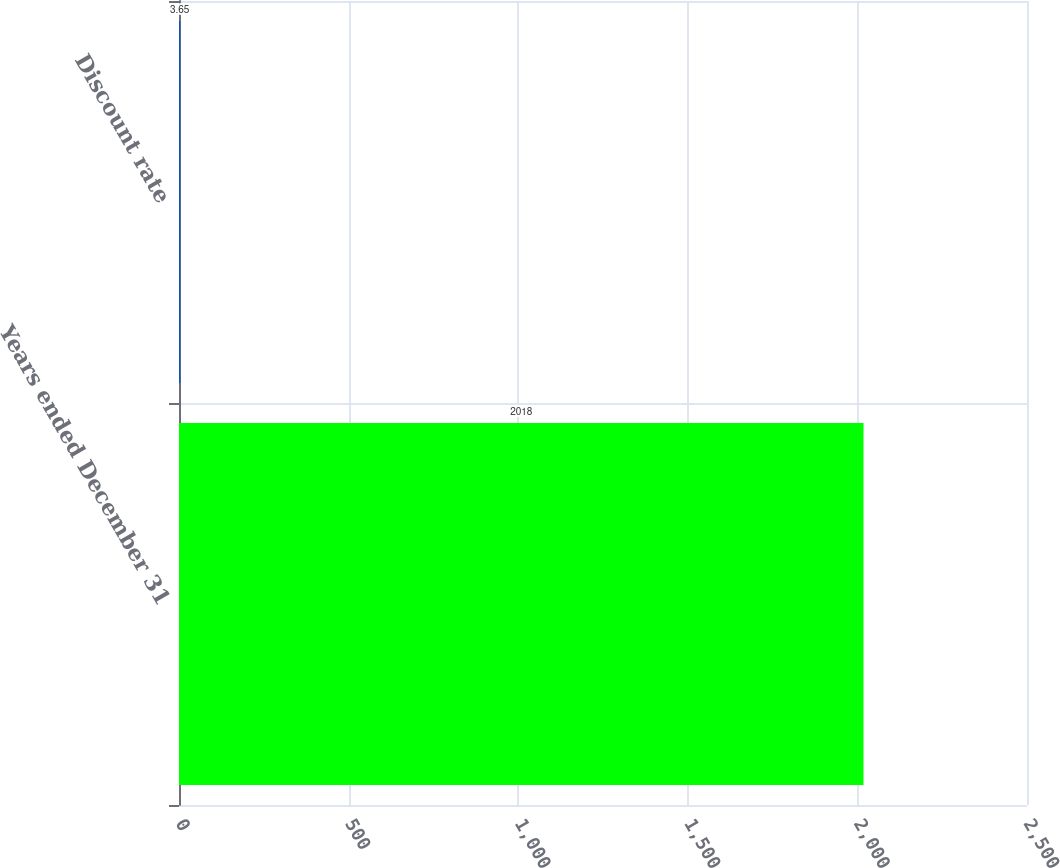Convert chart to OTSL. <chart><loc_0><loc_0><loc_500><loc_500><bar_chart><fcel>Years ended December 31<fcel>Discount rate<nl><fcel>2018<fcel>3.65<nl></chart> 